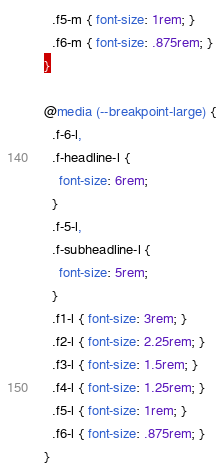Convert code to text. <code><loc_0><loc_0><loc_500><loc_500><_CSS_>  .f5-m { font-size: 1rem; }
  .f6-m { font-size: .875rem; }
}

@media (--breakpoint-large) {
  .f-6-l,
  .f-headline-l {
    font-size: 6rem;
  }
  .f-5-l,
  .f-subheadline-l {
    font-size: 5rem;
  }
  .f1-l { font-size: 3rem; }
  .f2-l { font-size: 2.25rem; }
  .f3-l { font-size: 1.5rem; }
  .f4-l { font-size: 1.25rem; }
  .f5-l { font-size: 1rem; }
  .f6-l { font-size: .875rem; }
}
</code> 